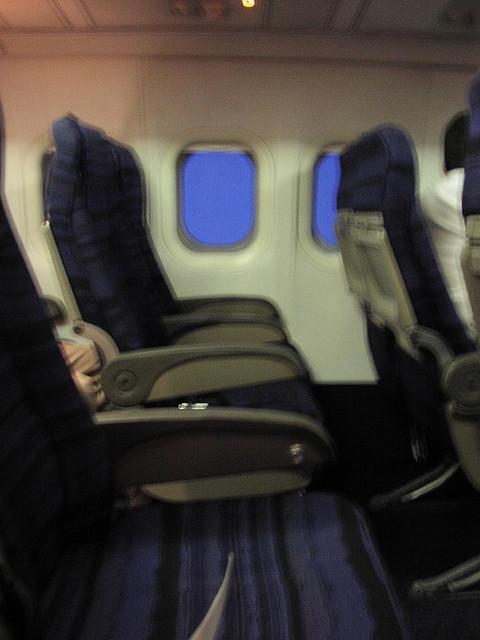Where are the seats placed inside?
Make your selection from the four choices given to correctly answer the question.
Options: Subway, sedan, van, airplane. Airplane. 